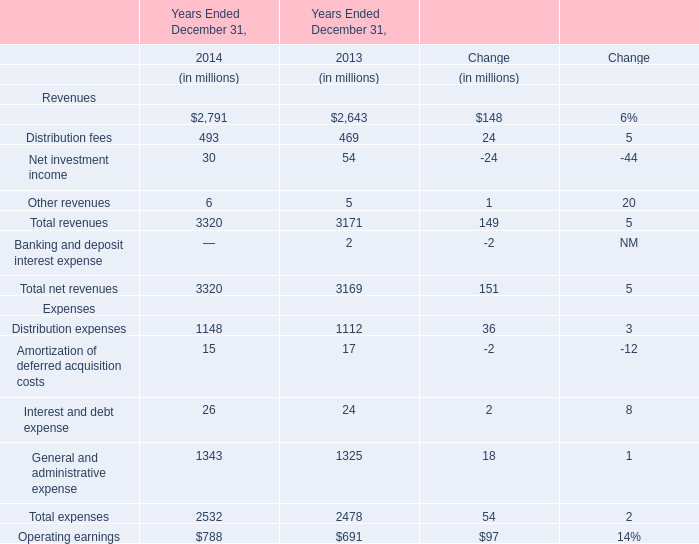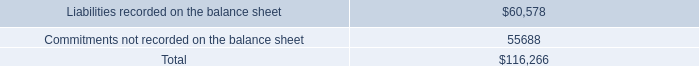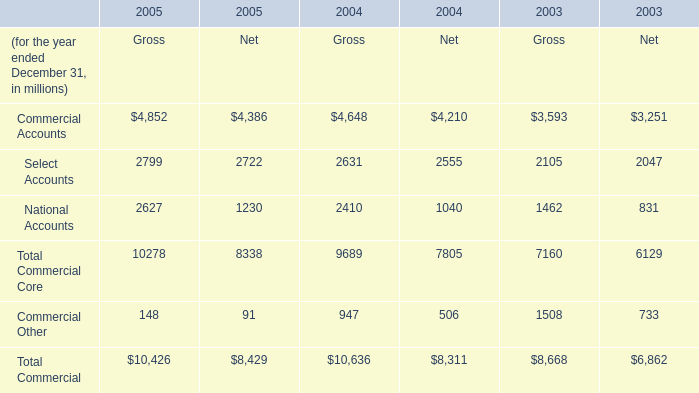What's the total amount of the Total revenues in the years where Distribution fees greater than 490? (in million) 
Computations: (((2791 + 493) + 30) + 6)
Answer: 3320.0. 